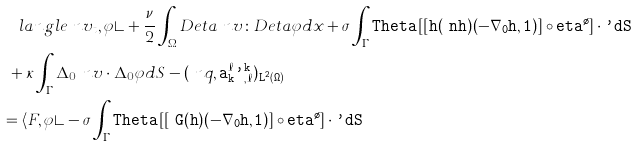Convert formula to latex. <formula><loc_0><loc_0><loc_500><loc_500>& \quad l a n g l e \ n v _ { t } , \varphi \rangle + \frac { \nu } { 2 } \int _ { \Omega } D _ { \tt } e t a \ n v \colon D _ { \tt } e t a \varphi d x + \sigma \int _ { \Gamma } \tt T h e t a \left [ [ \L _ { \tt } h ( \ n h ) ( - \nabla _ { 0 } \tt h , 1 ) ] \circ \tt e t a ^ { \tau } \right ] \cdot \varphi d S \\ & \ + \kappa \int _ { \Gamma } \Delta _ { 0 } \ n v \cdot \Delta _ { 0 } \varphi d S - ( \ n q , \tt a _ { k } ^ { \ell } \varphi _ { , \ell } ^ { k } ) _ { L ^ { 2 } ( \Omega ) } \\ & = \langle F , \varphi \rangle - \sigma \int _ { \Gamma } \tt T h e t a \left [ [ \ G ( \tt h ) ( - \nabla _ { 0 } \tt h , 1 ) ] \circ \tt e t a ^ { \tau } \right ] \cdot \varphi d S</formula> 